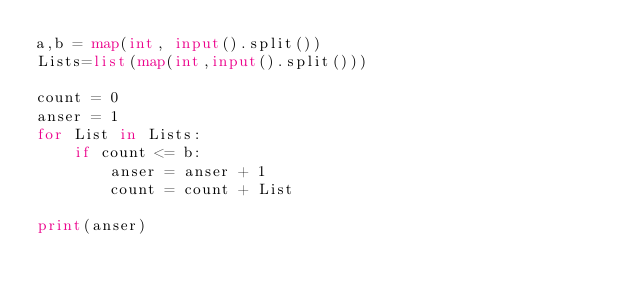<code> <loc_0><loc_0><loc_500><loc_500><_Python_>a,b = map(int, input().split())
Lists=list(map(int,input().split()))

count = 0
anser = 1
for List in Lists:
    if count <= b:
        anser = anser + 1
        count = count + List
        
print(anser)    
</code> 